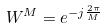<formula> <loc_0><loc_0><loc_500><loc_500>W ^ { M } = e ^ { - j \frac { 2 \pi } { M } }</formula> 